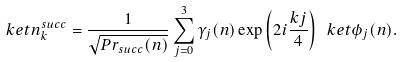Convert formula to latex. <formula><loc_0><loc_0><loc_500><loc_500>\ k e t { n _ { k } ^ { s u c c } } = \frac { 1 } { \sqrt { P r _ { s u c c } ( n ) } } \sum _ { j = 0 } ^ { 3 } \gamma _ { j } ( n ) \exp \left ( 2 i \frac { k j } { 4 } \right ) \ k e t { \phi _ { j } ( n ) } .</formula> 